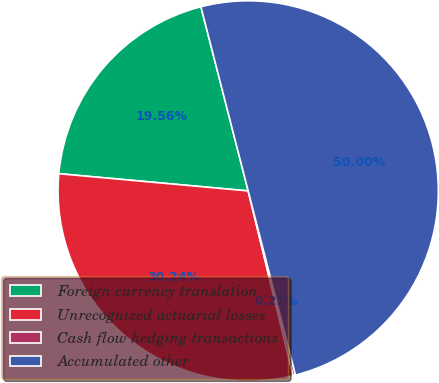Convert chart to OTSL. <chart><loc_0><loc_0><loc_500><loc_500><pie_chart><fcel>Foreign currency translation<fcel>Unrecognized actuarial losses<fcel>Cash flow hedging transactions<fcel>Accumulated other<nl><fcel>19.56%<fcel>30.24%<fcel>0.21%<fcel>50.0%<nl></chart> 